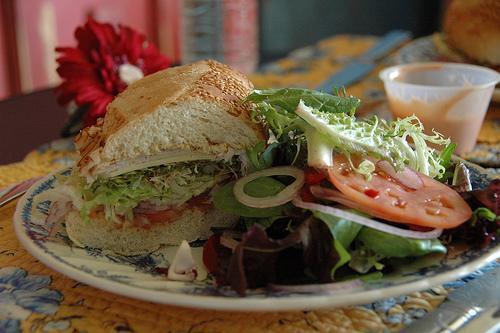How many flowers are shown?
Give a very brief answer. 1. 